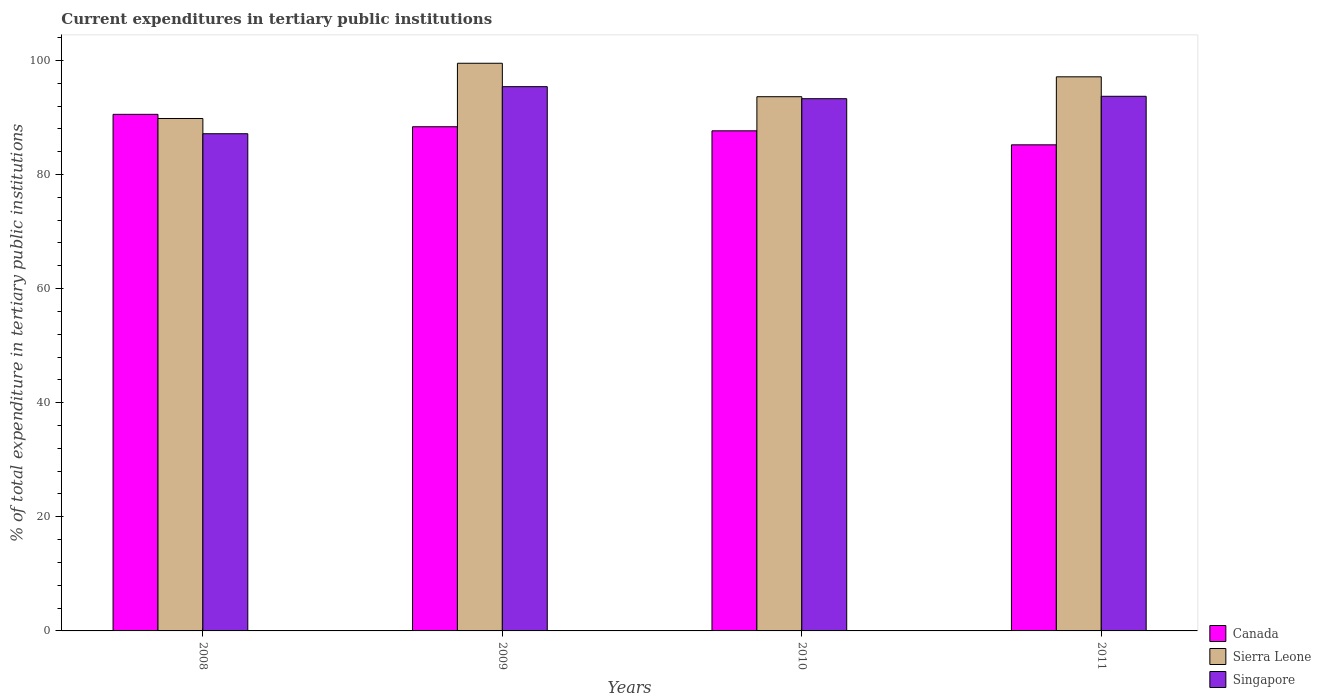How many different coloured bars are there?
Offer a very short reply. 3. How many groups of bars are there?
Keep it short and to the point. 4. Are the number of bars per tick equal to the number of legend labels?
Your answer should be compact. Yes. Are the number of bars on each tick of the X-axis equal?
Keep it short and to the point. Yes. How many bars are there on the 4th tick from the left?
Give a very brief answer. 3. How many bars are there on the 2nd tick from the right?
Your answer should be very brief. 3. What is the label of the 4th group of bars from the left?
Offer a terse response. 2011. What is the current expenditures in tertiary public institutions in Canada in 2011?
Provide a short and direct response. 85.2. Across all years, what is the maximum current expenditures in tertiary public institutions in Canada?
Your response must be concise. 90.54. Across all years, what is the minimum current expenditures in tertiary public institutions in Singapore?
Ensure brevity in your answer.  87.14. In which year was the current expenditures in tertiary public institutions in Singapore minimum?
Provide a short and direct response. 2008. What is the total current expenditures in tertiary public institutions in Singapore in the graph?
Provide a short and direct response. 369.51. What is the difference between the current expenditures in tertiary public institutions in Singapore in 2008 and that in 2010?
Offer a very short reply. -6.14. What is the difference between the current expenditures in tertiary public institutions in Canada in 2010 and the current expenditures in tertiary public institutions in Sierra Leone in 2009?
Your answer should be compact. -11.84. What is the average current expenditures in tertiary public institutions in Singapore per year?
Provide a short and direct response. 92.38. In the year 2011, what is the difference between the current expenditures in tertiary public institutions in Canada and current expenditures in tertiary public institutions in Singapore?
Your answer should be very brief. -8.51. In how many years, is the current expenditures in tertiary public institutions in Singapore greater than 68 %?
Your answer should be very brief. 4. What is the ratio of the current expenditures in tertiary public institutions in Singapore in 2009 to that in 2011?
Keep it short and to the point. 1.02. What is the difference between the highest and the second highest current expenditures in tertiary public institutions in Canada?
Give a very brief answer. 2.17. What is the difference between the highest and the lowest current expenditures in tertiary public institutions in Sierra Leone?
Ensure brevity in your answer.  9.68. In how many years, is the current expenditures in tertiary public institutions in Sierra Leone greater than the average current expenditures in tertiary public institutions in Sierra Leone taken over all years?
Your answer should be very brief. 2. What does the 2nd bar from the left in 2011 represents?
Keep it short and to the point. Sierra Leone. What does the 1st bar from the right in 2010 represents?
Ensure brevity in your answer.  Singapore. How many years are there in the graph?
Your answer should be very brief. 4. Are the values on the major ticks of Y-axis written in scientific E-notation?
Your answer should be compact. No. Does the graph contain any zero values?
Provide a succinct answer. No. Does the graph contain grids?
Give a very brief answer. No. What is the title of the graph?
Provide a succinct answer. Current expenditures in tertiary public institutions. What is the label or title of the X-axis?
Your response must be concise. Years. What is the label or title of the Y-axis?
Make the answer very short. % of total expenditure in tertiary public institutions. What is the % of total expenditure in tertiary public institutions of Canada in 2008?
Give a very brief answer. 90.54. What is the % of total expenditure in tertiary public institutions in Sierra Leone in 2008?
Provide a succinct answer. 89.81. What is the % of total expenditure in tertiary public institutions of Singapore in 2008?
Make the answer very short. 87.14. What is the % of total expenditure in tertiary public institutions in Canada in 2009?
Give a very brief answer. 88.37. What is the % of total expenditure in tertiary public institutions in Sierra Leone in 2009?
Give a very brief answer. 99.49. What is the % of total expenditure in tertiary public institutions in Singapore in 2009?
Offer a terse response. 95.39. What is the % of total expenditure in tertiary public institutions in Canada in 2010?
Your response must be concise. 87.65. What is the % of total expenditure in tertiary public institutions in Sierra Leone in 2010?
Keep it short and to the point. 93.63. What is the % of total expenditure in tertiary public institutions of Singapore in 2010?
Make the answer very short. 93.28. What is the % of total expenditure in tertiary public institutions in Canada in 2011?
Your response must be concise. 85.2. What is the % of total expenditure in tertiary public institutions of Sierra Leone in 2011?
Provide a short and direct response. 97.12. What is the % of total expenditure in tertiary public institutions of Singapore in 2011?
Offer a very short reply. 93.7. Across all years, what is the maximum % of total expenditure in tertiary public institutions in Canada?
Your answer should be very brief. 90.54. Across all years, what is the maximum % of total expenditure in tertiary public institutions in Sierra Leone?
Ensure brevity in your answer.  99.49. Across all years, what is the maximum % of total expenditure in tertiary public institutions in Singapore?
Offer a terse response. 95.39. Across all years, what is the minimum % of total expenditure in tertiary public institutions of Canada?
Provide a short and direct response. 85.2. Across all years, what is the minimum % of total expenditure in tertiary public institutions of Sierra Leone?
Offer a very short reply. 89.81. Across all years, what is the minimum % of total expenditure in tertiary public institutions in Singapore?
Your response must be concise. 87.14. What is the total % of total expenditure in tertiary public institutions of Canada in the graph?
Provide a short and direct response. 351.75. What is the total % of total expenditure in tertiary public institutions of Sierra Leone in the graph?
Offer a terse response. 380.05. What is the total % of total expenditure in tertiary public institutions of Singapore in the graph?
Provide a short and direct response. 369.51. What is the difference between the % of total expenditure in tertiary public institutions of Canada in 2008 and that in 2009?
Ensure brevity in your answer.  2.17. What is the difference between the % of total expenditure in tertiary public institutions of Sierra Leone in 2008 and that in 2009?
Provide a short and direct response. -9.68. What is the difference between the % of total expenditure in tertiary public institutions in Singapore in 2008 and that in 2009?
Your response must be concise. -8.25. What is the difference between the % of total expenditure in tertiary public institutions of Canada in 2008 and that in 2010?
Your response must be concise. 2.89. What is the difference between the % of total expenditure in tertiary public institutions of Sierra Leone in 2008 and that in 2010?
Offer a terse response. -3.82. What is the difference between the % of total expenditure in tertiary public institutions of Singapore in 2008 and that in 2010?
Offer a terse response. -6.14. What is the difference between the % of total expenditure in tertiary public institutions of Canada in 2008 and that in 2011?
Offer a terse response. 5.34. What is the difference between the % of total expenditure in tertiary public institutions of Sierra Leone in 2008 and that in 2011?
Your response must be concise. -7.3. What is the difference between the % of total expenditure in tertiary public institutions in Singapore in 2008 and that in 2011?
Offer a terse response. -6.56. What is the difference between the % of total expenditure in tertiary public institutions of Canada in 2009 and that in 2010?
Offer a terse response. 0.71. What is the difference between the % of total expenditure in tertiary public institutions in Sierra Leone in 2009 and that in 2010?
Your answer should be very brief. 5.86. What is the difference between the % of total expenditure in tertiary public institutions of Singapore in 2009 and that in 2010?
Your response must be concise. 2.11. What is the difference between the % of total expenditure in tertiary public institutions of Canada in 2009 and that in 2011?
Provide a succinct answer. 3.17. What is the difference between the % of total expenditure in tertiary public institutions of Sierra Leone in 2009 and that in 2011?
Make the answer very short. 2.38. What is the difference between the % of total expenditure in tertiary public institutions of Singapore in 2009 and that in 2011?
Keep it short and to the point. 1.69. What is the difference between the % of total expenditure in tertiary public institutions of Canada in 2010 and that in 2011?
Keep it short and to the point. 2.45. What is the difference between the % of total expenditure in tertiary public institutions of Sierra Leone in 2010 and that in 2011?
Your answer should be compact. -3.49. What is the difference between the % of total expenditure in tertiary public institutions in Singapore in 2010 and that in 2011?
Provide a short and direct response. -0.42. What is the difference between the % of total expenditure in tertiary public institutions of Canada in 2008 and the % of total expenditure in tertiary public institutions of Sierra Leone in 2009?
Provide a short and direct response. -8.95. What is the difference between the % of total expenditure in tertiary public institutions in Canada in 2008 and the % of total expenditure in tertiary public institutions in Singapore in 2009?
Provide a succinct answer. -4.85. What is the difference between the % of total expenditure in tertiary public institutions of Sierra Leone in 2008 and the % of total expenditure in tertiary public institutions of Singapore in 2009?
Ensure brevity in your answer.  -5.58. What is the difference between the % of total expenditure in tertiary public institutions of Canada in 2008 and the % of total expenditure in tertiary public institutions of Sierra Leone in 2010?
Provide a short and direct response. -3.09. What is the difference between the % of total expenditure in tertiary public institutions of Canada in 2008 and the % of total expenditure in tertiary public institutions of Singapore in 2010?
Offer a terse response. -2.74. What is the difference between the % of total expenditure in tertiary public institutions in Sierra Leone in 2008 and the % of total expenditure in tertiary public institutions in Singapore in 2010?
Provide a succinct answer. -3.47. What is the difference between the % of total expenditure in tertiary public institutions of Canada in 2008 and the % of total expenditure in tertiary public institutions of Sierra Leone in 2011?
Make the answer very short. -6.58. What is the difference between the % of total expenditure in tertiary public institutions of Canada in 2008 and the % of total expenditure in tertiary public institutions of Singapore in 2011?
Offer a very short reply. -3.17. What is the difference between the % of total expenditure in tertiary public institutions of Sierra Leone in 2008 and the % of total expenditure in tertiary public institutions of Singapore in 2011?
Provide a short and direct response. -3.89. What is the difference between the % of total expenditure in tertiary public institutions in Canada in 2009 and the % of total expenditure in tertiary public institutions in Sierra Leone in 2010?
Provide a short and direct response. -5.26. What is the difference between the % of total expenditure in tertiary public institutions in Canada in 2009 and the % of total expenditure in tertiary public institutions in Singapore in 2010?
Provide a succinct answer. -4.92. What is the difference between the % of total expenditure in tertiary public institutions of Sierra Leone in 2009 and the % of total expenditure in tertiary public institutions of Singapore in 2010?
Make the answer very short. 6.21. What is the difference between the % of total expenditure in tertiary public institutions in Canada in 2009 and the % of total expenditure in tertiary public institutions in Sierra Leone in 2011?
Ensure brevity in your answer.  -8.75. What is the difference between the % of total expenditure in tertiary public institutions in Canada in 2009 and the % of total expenditure in tertiary public institutions in Singapore in 2011?
Your answer should be very brief. -5.34. What is the difference between the % of total expenditure in tertiary public institutions in Sierra Leone in 2009 and the % of total expenditure in tertiary public institutions in Singapore in 2011?
Offer a terse response. 5.79. What is the difference between the % of total expenditure in tertiary public institutions of Canada in 2010 and the % of total expenditure in tertiary public institutions of Sierra Leone in 2011?
Provide a succinct answer. -9.47. What is the difference between the % of total expenditure in tertiary public institutions of Canada in 2010 and the % of total expenditure in tertiary public institutions of Singapore in 2011?
Your answer should be very brief. -6.05. What is the difference between the % of total expenditure in tertiary public institutions of Sierra Leone in 2010 and the % of total expenditure in tertiary public institutions of Singapore in 2011?
Make the answer very short. -0.07. What is the average % of total expenditure in tertiary public institutions of Canada per year?
Your answer should be very brief. 87.94. What is the average % of total expenditure in tertiary public institutions in Sierra Leone per year?
Ensure brevity in your answer.  95.01. What is the average % of total expenditure in tertiary public institutions in Singapore per year?
Your response must be concise. 92.38. In the year 2008, what is the difference between the % of total expenditure in tertiary public institutions in Canada and % of total expenditure in tertiary public institutions in Sierra Leone?
Give a very brief answer. 0.73. In the year 2008, what is the difference between the % of total expenditure in tertiary public institutions in Canada and % of total expenditure in tertiary public institutions in Singapore?
Your answer should be compact. 3.4. In the year 2008, what is the difference between the % of total expenditure in tertiary public institutions of Sierra Leone and % of total expenditure in tertiary public institutions of Singapore?
Provide a short and direct response. 2.67. In the year 2009, what is the difference between the % of total expenditure in tertiary public institutions of Canada and % of total expenditure in tertiary public institutions of Sierra Leone?
Provide a succinct answer. -11.13. In the year 2009, what is the difference between the % of total expenditure in tertiary public institutions in Canada and % of total expenditure in tertiary public institutions in Singapore?
Keep it short and to the point. -7.02. In the year 2009, what is the difference between the % of total expenditure in tertiary public institutions in Sierra Leone and % of total expenditure in tertiary public institutions in Singapore?
Your answer should be compact. 4.1. In the year 2010, what is the difference between the % of total expenditure in tertiary public institutions of Canada and % of total expenditure in tertiary public institutions of Sierra Leone?
Give a very brief answer. -5.98. In the year 2010, what is the difference between the % of total expenditure in tertiary public institutions in Canada and % of total expenditure in tertiary public institutions in Singapore?
Provide a succinct answer. -5.63. In the year 2010, what is the difference between the % of total expenditure in tertiary public institutions of Sierra Leone and % of total expenditure in tertiary public institutions of Singapore?
Give a very brief answer. 0.35. In the year 2011, what is the difference between the % of total expenditure in tertiary public institutions of Canada and % of total expenditure in tertiary public institutions of Sierra Leone?
Offer a terse response. -11.92. In the year 2011, what is the difference between the % of total expenditure in tertiary public institutions of Canada and % of total expenditure in tertiary public institutions of Singapore?
Your answer should be very brief. -8.51. In the year 2011, what is the difference between the % of total expenditure in tertiary public institutions in Sierra Leone and % of total expenditure in tertiary public institutions in Singapore?
Your response must be concise. 3.41. What is the ratio of the % of total expenditure in tertiary public institutions in Canada in 2008 to that in 2009?
Keep it short and to the point. 1.02. What is the ratio of the % of total expenditure in tertiary public institutions of Sierra Leone in 2008 to that in 2009?
Provide a succinct answer. 0.9. What is the ratio of the % of total expenditure in tertiary public institutions in Singapore in 2008 to that in 2009?
Offer a very short reply. 0.91. What is the ratio of the % of total expenditure in tertiary public institutions in Canada in 2008 to that in 2010?
Your answer should be very brief. 1.03. What is the ratio of the % of total expenditure in tertiary public institutions in Sierra Leone in 2008 to that in 2010?
Provide a succinct answer. 0.96. What is the ratio of the % of total expenditure in tertiary public institutions in Singapore in 2008 to that in 2010?
Keep it short and to the point. 0.93. What is the ratio of the % of total expenditure in tertiary public institutions of Canada in 2008 to that in 2011?
Ensure brevity in your answer.  1.06. What is the ratio of the % of total expenditure in tertiary public institutions of Sierra Leone in 2008 to that in 2011?
Your answer should be compact. 0.92. What is the ratio of the % of total expenditure in tertiary public institutions of Canada in 2009 to that in 2010?
Provide a succinct answer. 1.01. What is the ratio of the % of total expenditure in tertiary public institutions of Sierra Leone in 2009 to that in 2010?
Your response must be concise. 1.06. What is the ratio of the % of total expenditure in tertiary public institutions of Singapore in 2009 to that in 2010?
Your answer should be very brief. 1.02. What is the ratio of the % of total expenditure in tertiary public institutions in Canada in 2009 to that in 2011?
Provide a short and direct response. 1.04. What is the ratio of the % of total expenditure in tertiary public institutions of Sierra Leone in 2009 to that in 2011?
Offer a very short reply. 1.02. What is the ratio of the % of total expenditure in tertiary public institutions in Singapore in 2009 to that in 2011?
Your answer should be very brief. 1.02. What is the ratio of the % of total expenditure in tertiary public institutions of Canada in 2010 to that in 2011?
Provide a short and direct response. 1.03. What is the ratio of the % of total expenditure in tertiary public institutions of Sierra Leone in 2010 to that in 2011?
Provide a succinct answer. 0.96. What is the difference between the highest and the second highest % of total expenditure in tertiary public institutions of Canada?
Provide a short and direct response. 2.17. What is the difference between the highest and the second highest % of total expenditure in tertiary public institutions of Sierra Leone?
Offer a very short reply. 2.38. What is the difference between the highest and the second highest % of total expenditure in tertiary public institutions in Singapore?
Ensure brevity in your answer.  1.69. What is the difference between the highest and the lowest % of total expenditure in tertiary public institutions of Canada?
Ensure brevity in your answer.  5.34. What is the difference between the highest and the lowest % of total expenditure in tertiary public institutions in Sierra Leone?
Ensure brevity in your answer.  9.68. What is the difference between the highest and the lowest % of total expenditure in tertiary public institutions in Singapore?
Offer a very short reply. 8.25. 